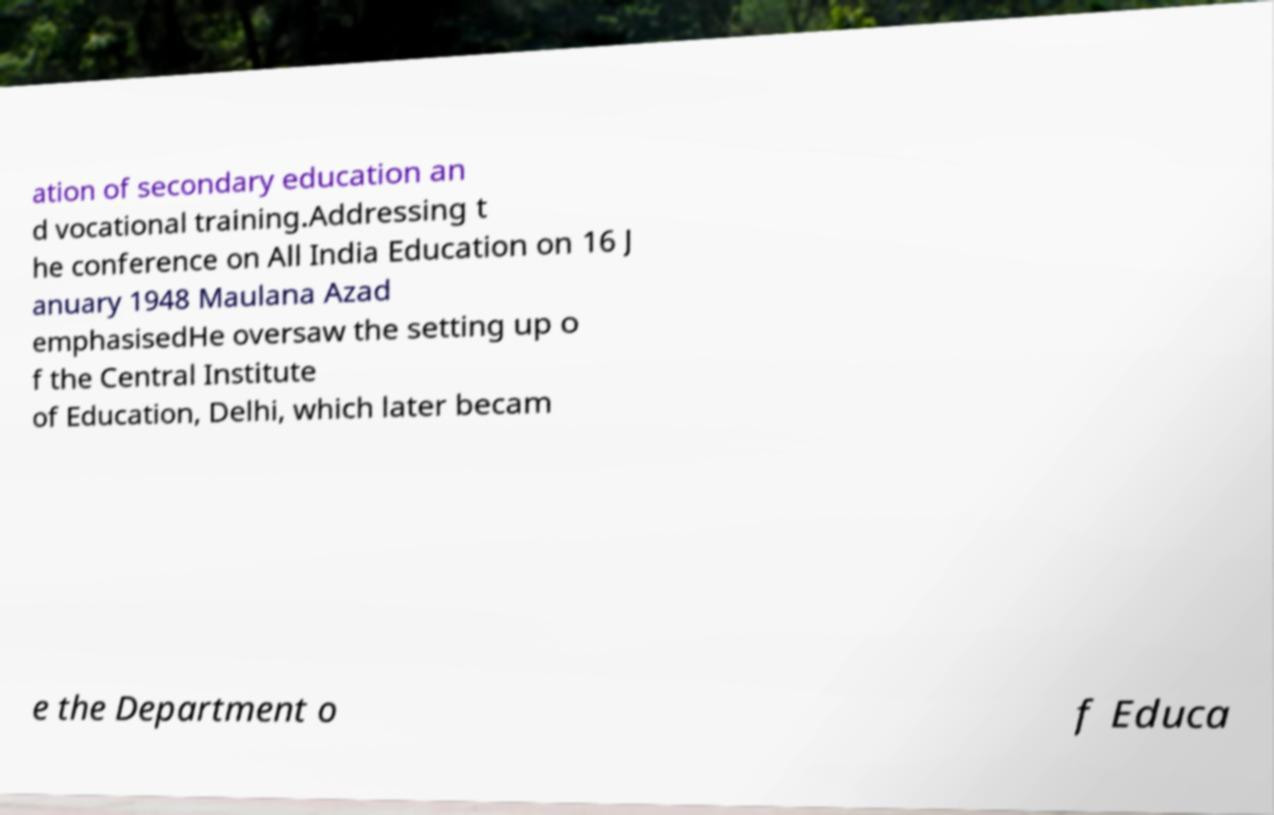For documentation purposes, I need the text within this image transcribed. Could you provide that? ation of secondary education an d vocational training.Addressing t he conference on All India Education on 16 J anuary 1948 Maulana Azad emphasisedHe oversaw the setting up o f the Central Institute of Education, Delhi, which later becam e the Department o f Educa 